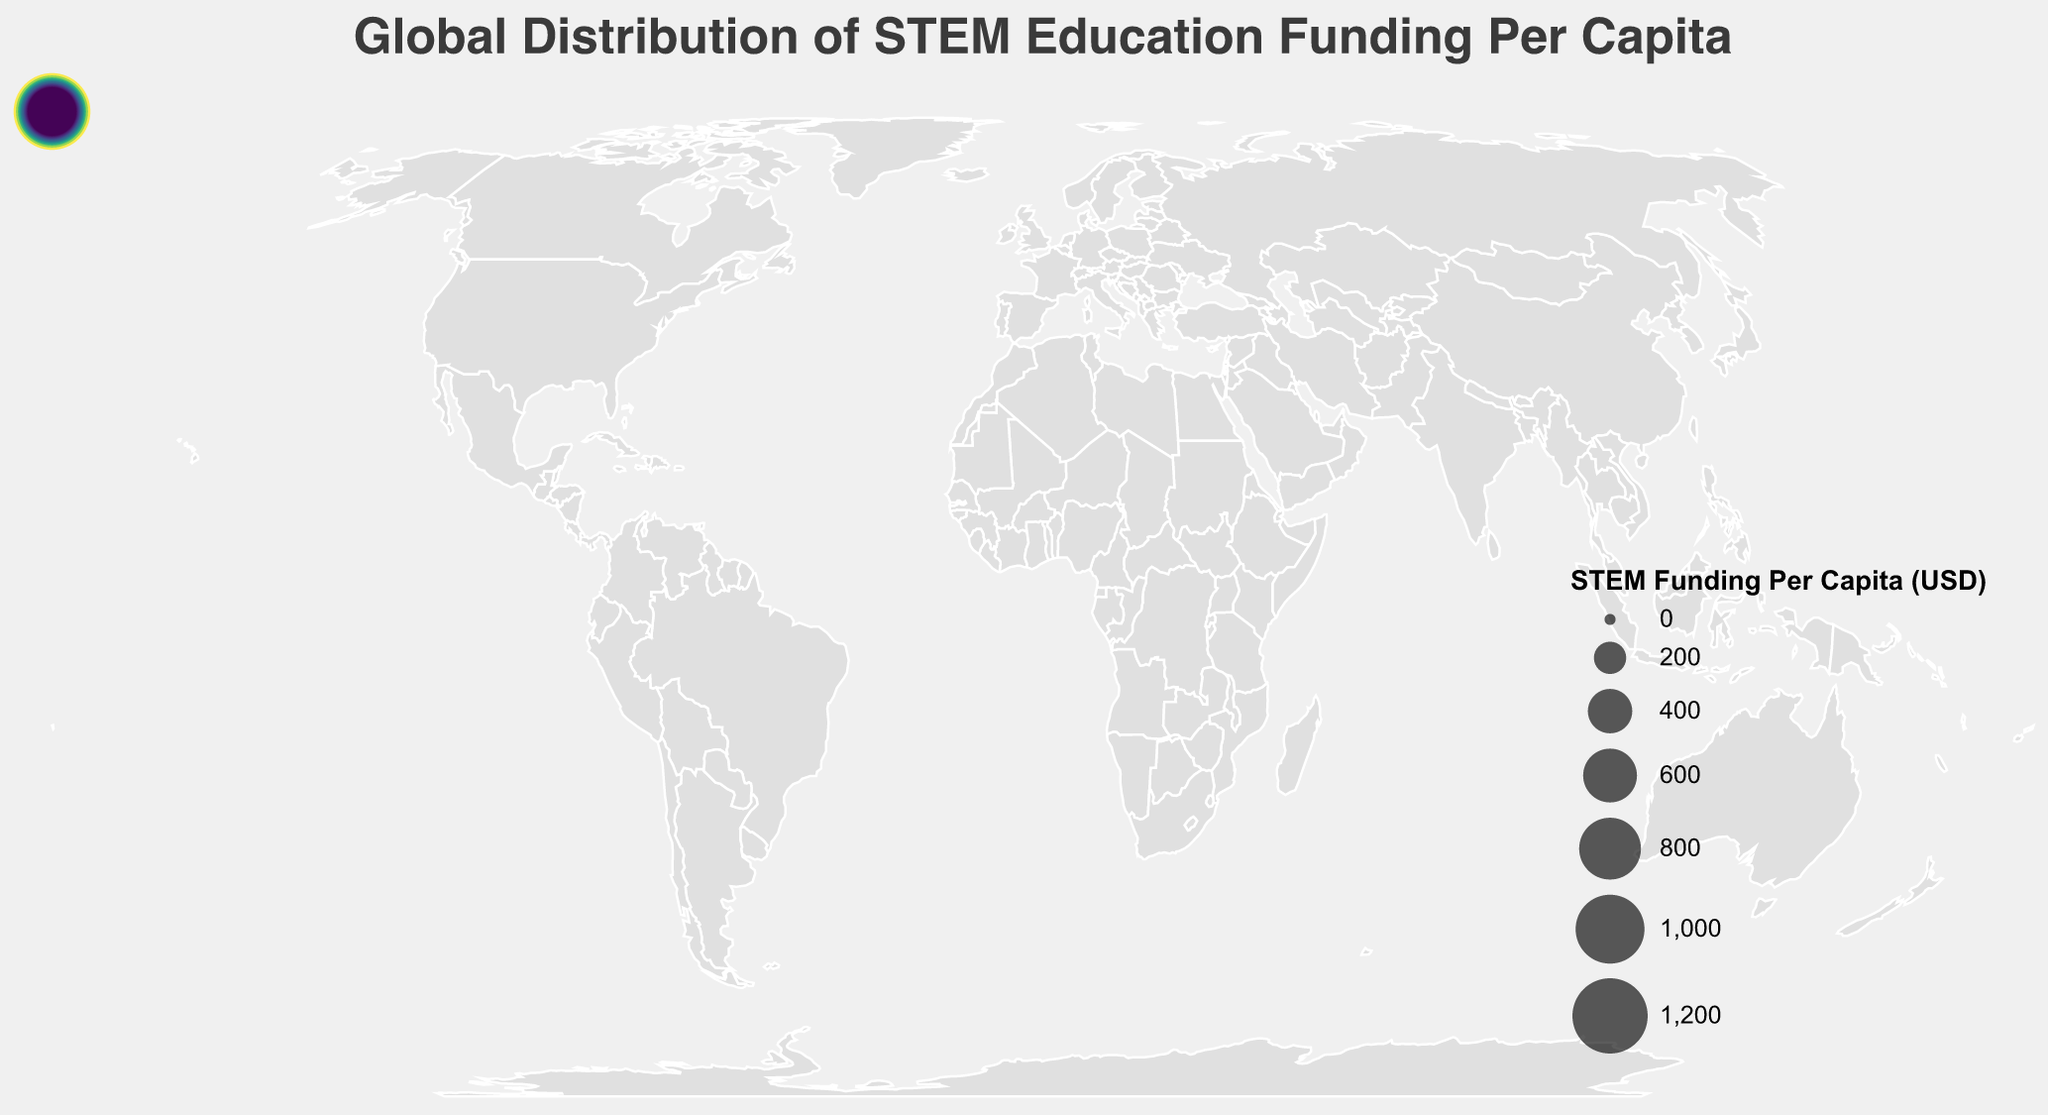What is the title of the figure? The title is displayed prominently at the top of the figure. It reads "Global Distribution of STEM Education Funding Per Capita".
Answer: Global Distribution of STEM Education Funding Per Capita Which country has the highest STEM education funding per capita? By looking at the size of the circles, the United States has the largest one, indicating the highest per capita funding. The tooltip also confirms this.
Answer: United States Which country has the lowest STEM education funding per capita? By examining the smaller circles, New Zealand has the smallest one, indicating the lowest per capita funding. The tooltip confirms this.
Answer: New Zealand What is the STEM education funding per capita in Finland? Hovering over Finland reveals the tooltip, which shows the STEM education funding per capita as $1100.
Answer: $1100 How many countries have a STEM education funding per capita greater than $800? Visually identify all circles larger than the $800 benchmark and count them: United States, Finland, Singapore, Japan, Germany, and South Korea. There are 6 countries.
Answer: 6 What is the range of STEM education funding per capita values in the data? Identify the highest and lowest values from the tooltip data. The highest is $1250 (United States) and the lowest is $490 (New Zealand). The range is $1250 - $490.
Answer: $760 Which continents are represented in the top 5 countries for STEM education funding per capita? The top 5 countries are the United States, Finland, Singapore, Japan, and Germany. These countries are from North America, Europe, Asia, Asia, and Europe, respectively.
Answer: North America, Europe, Asia What is the average STEM education funding per capita for countries in Europe? The European countries listed with their funding are Finland ($1100), Germany ($850), United Kingdom ($780), Netherlands ($720), Sweden ($630), France ($610), Switzerland ($590), Estonia ($570), Denmark ($550), Norway ($530), Ireland ($510). Sum these values: 1100 + 850 + 780 + 720 + 630 + 610 + 590 + 570 + 550 + 530 + 510 = 7440. There are 11 countries, so the average is 7440 / 11.
Answer: $676.36 Compare the STEM education funding per capita between Japan and South Korea. Which is higher and by how much? From the figure, Japan has $920 and South Korea has $830. The difference is $920 - $830.
Answer: Japan by $90 